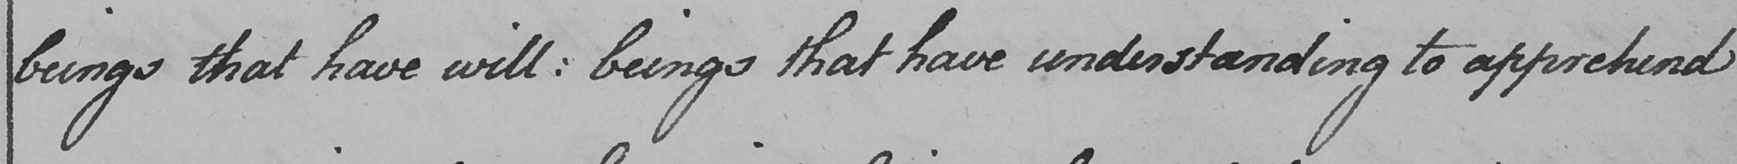Can you read and transcribe this handwriting? beings that have will :  beings that have understanding to apprehend 